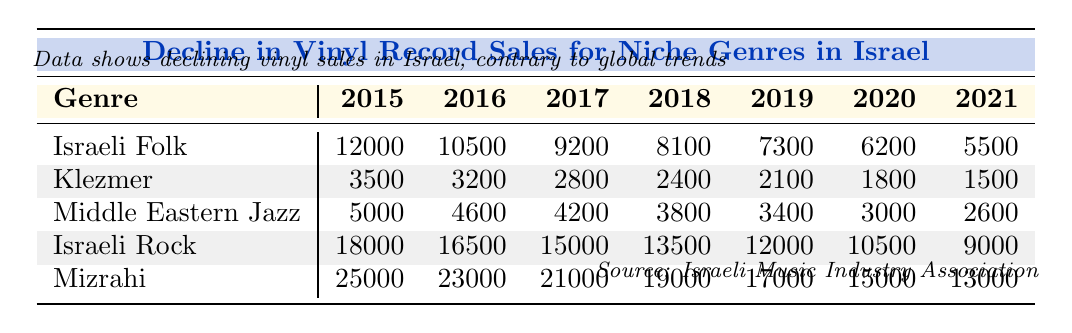What were the Israeli Folk vinyl sales in 2019? According to the table, the sales for Israeli Folk in 2019 are listed as 7300.
Answer: 7300 What was the decline in Klezmer vinyl sales from 2015 to 2021? In 2015, Klezmer sales were 3500, and by 2021 they fell to 1500. The decline is 3500 - 1500 = 2000.
Answer: 2000 Which genre had the highest vinyl sales in Israel in 2017? Looking at the 2017 column, Israeli Rock sales at 15000 were the highest compared to other genres.
Answer: Israeli Rock What was the average vinyl sales for Mizrahi from 2015 to 2021? The Mizrahi sales across those years are 25000, 23000, 21000, 19000, 17000, 15000, and 13000. The sum is 25000 + 23000 + 21000 + 19000 + 17000 + 15000 + 13000 = 133000, divided by 7 gives an average of 19000.
Answer: 19000 Did Middle Eastern Jazz sales increase at any point from 2015 to 2021? The sales started at 5000 in 2015 and declined each year, showing no increase during that period.
Answer: No By how much did the Israeli Rock vinyl sales drop from 2015 to 2021? Israeli Rock sales dropped from 18000 in 2015 to 9000 in 2021. The difference is 18000 - 9000 = 9000.
Answer: 9000 Which genre had the least vinyl sales in Israel in 2020? The 2020 sales show Klezmer with 1800, which is the smallest number compared to other genres in that year.
Answer: Klezmer What is the difference between the global sales of Israeli Folk and Klezmer in 2018? Israeli Folk global sales in 2018 were 52000 and Klezmer's were 18000. The difference is 52000 - 18000 = 34000.
Answer: 34000 What trend can be observed in the vinyl sales of Mizrahi from 2015 to 2021? Mizrahi sales decreased consistently from 25000 in 2015 to 13000 in 2021, indicating a downward trend.
Answer: Downward trend Which genre maintained the highest vinyl sales in Israel throughout 2015 to 2021? Examining the sales data indicates Mizrahi had the highest sales each year, peaking at 25000 in 2015 and dropping to 13000 by 2021.
Answer: Mizrahi 